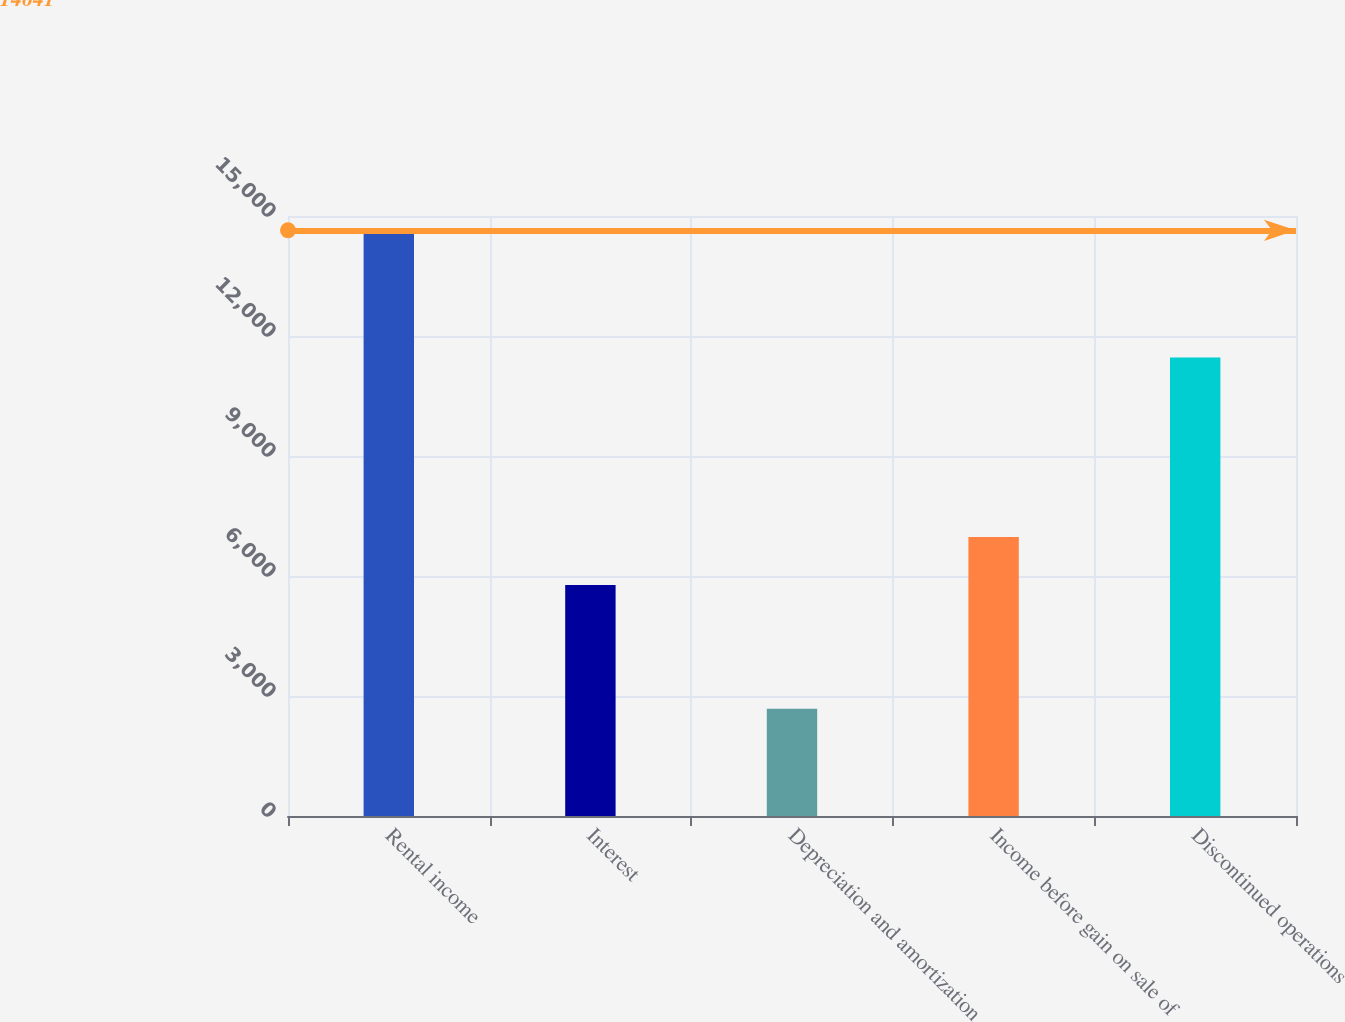Convert chart to OTSL. <chart><loc_0><loc_0><loc_500><loc_500><bar_chart><fcel>Rental income<fcel>Interest<fcel>Depreciation and amortization<fcel>Income before gain on sale of<fcel>Discontinued operations<nl><fcel>14641<fcel>5777<fcel>2682<fcel>6972.9<fcel>11461<nl></chart> 